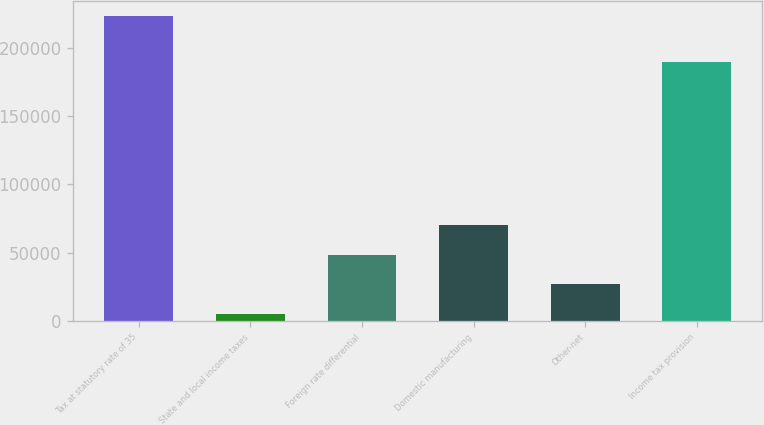Convert chart to OTSL. <chart><loc_0><loc_0><loc_500><loc_500><bar_chart><fcel>Tax at statutory rate of 35<fcel>State and local income taxes<fcel>Foreign rate differential<fcel>Domestic manufacturing<fcel>Other-net<fcel>Income tax provision<nl><fcel>222888<fcel>4931<fcel>48522.4<fcel>70318.1<fcel>26726.7<fcel>189612<nl></chart> 